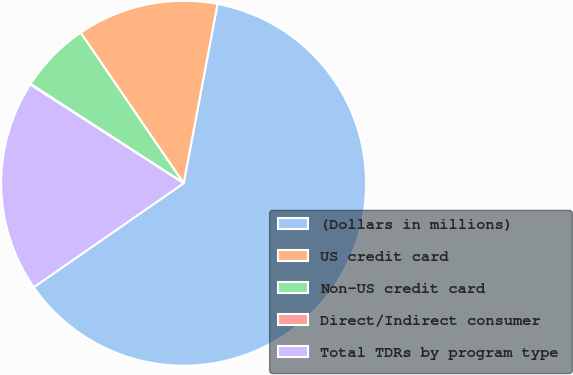Convert chart to OTSL. <chart><loc_0><loc_0><loc_500><loc_500><pie_chart><fcel>(Dollars in millions)<fcel>US credit card<fcel>Non-US credit card<fcel>Direct/Indirect consumer<fcel>Total TDRs by program type<nl><fcel>62.37%<fcel>12.52%<fcel>6.29%<fcel>0.06%<fcel>18.75%<nl></chart> 